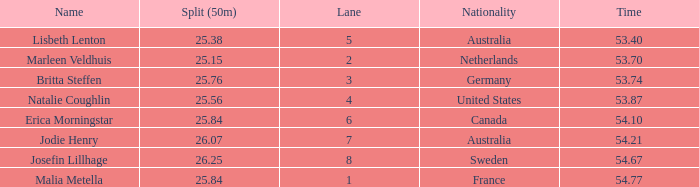Would you be able to parse every entry in this table? {'header': ['Name', 'Split (50m)', 'Lane', 'Nationality', 'Time'], 'rows': [['Lisbeth Lenton', '25.38', '5', 'Australia', '53.40'], ['Marleen Veldhuis', '25.15', '2', 'Netherlands', '53.70'], ['Britta Steffen', '25.76', '3', 'Germany', '53.74'], ['Natalie Coughlin', '25.56', '4', 'United States', '53.87'], ['Erica Morningstar', '25.84', '6', 'Canada', '54.10'], ['Jodie Henry', '26.07', '7', 'Australia', '54.21'], ['Josefin Lillhage', '26.25', '8', 'Sweden', '54.67'], ['Malia Metella', '25.84', '1', 'France', '54.77']]} What is the total of lane(s) for swimmers from Sweden with a 50m split of faster than 26.25? None. 